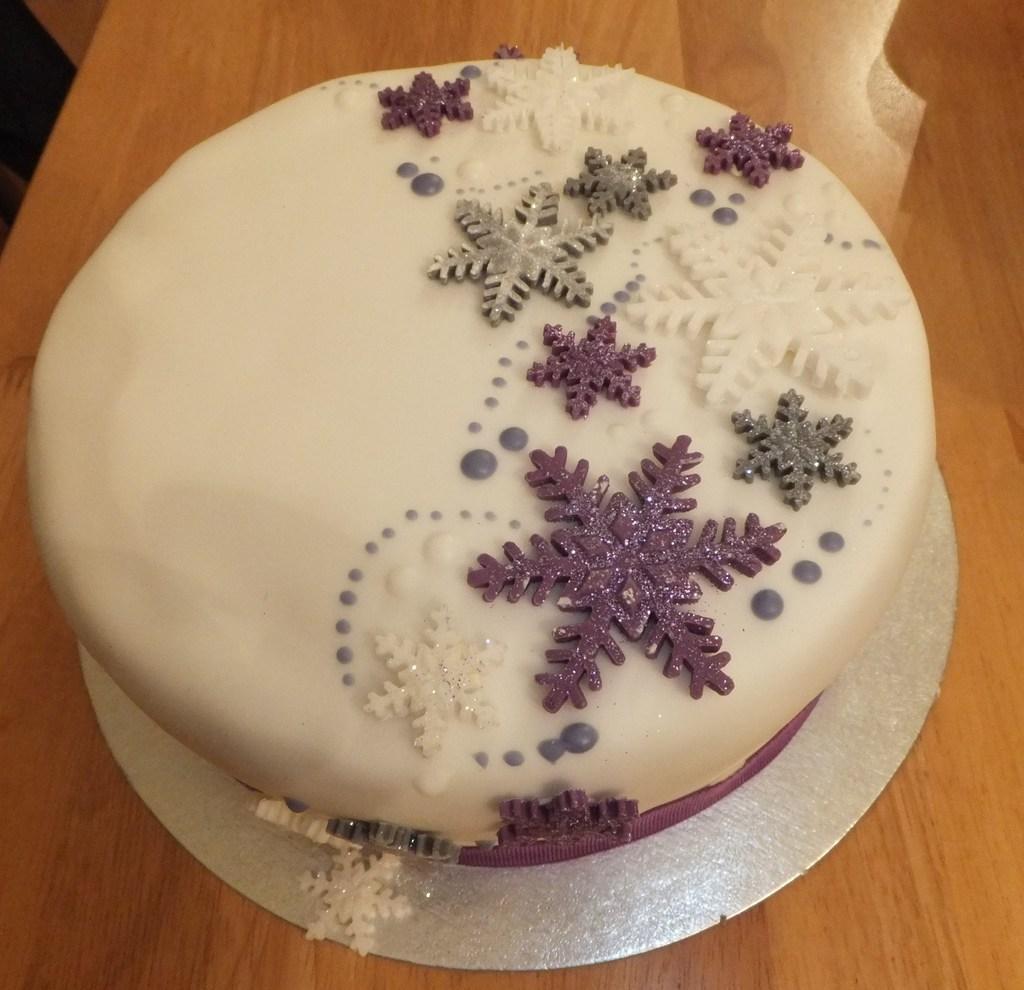How would you summarize this image in a sentence or two? The picture consists of a cake on a wooden table. 